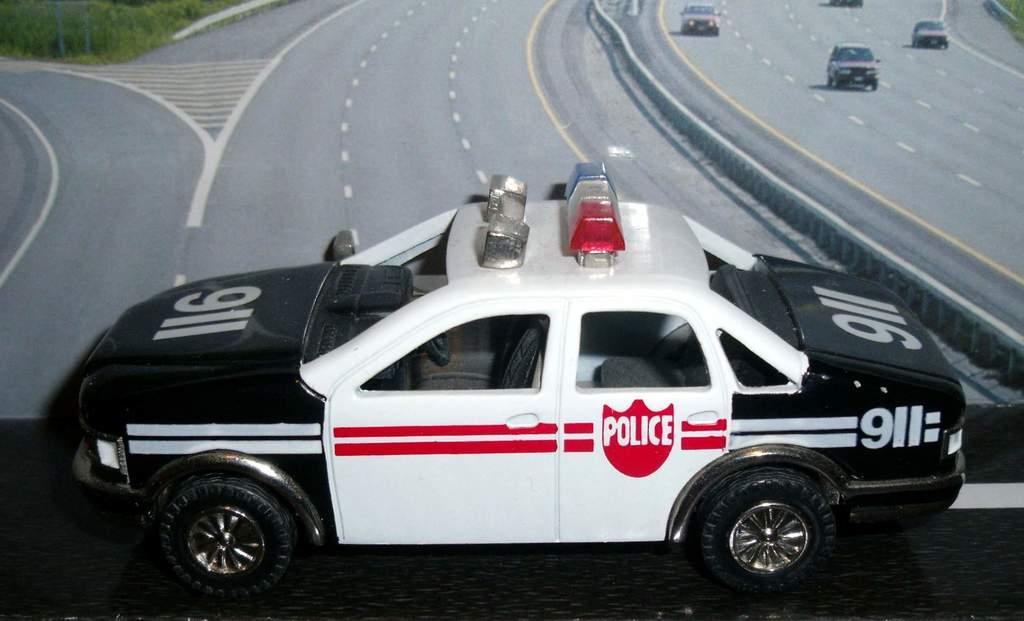Please provide a concise description of this image. In the image there is a police car kept in front of a poster and it is a toy car. 